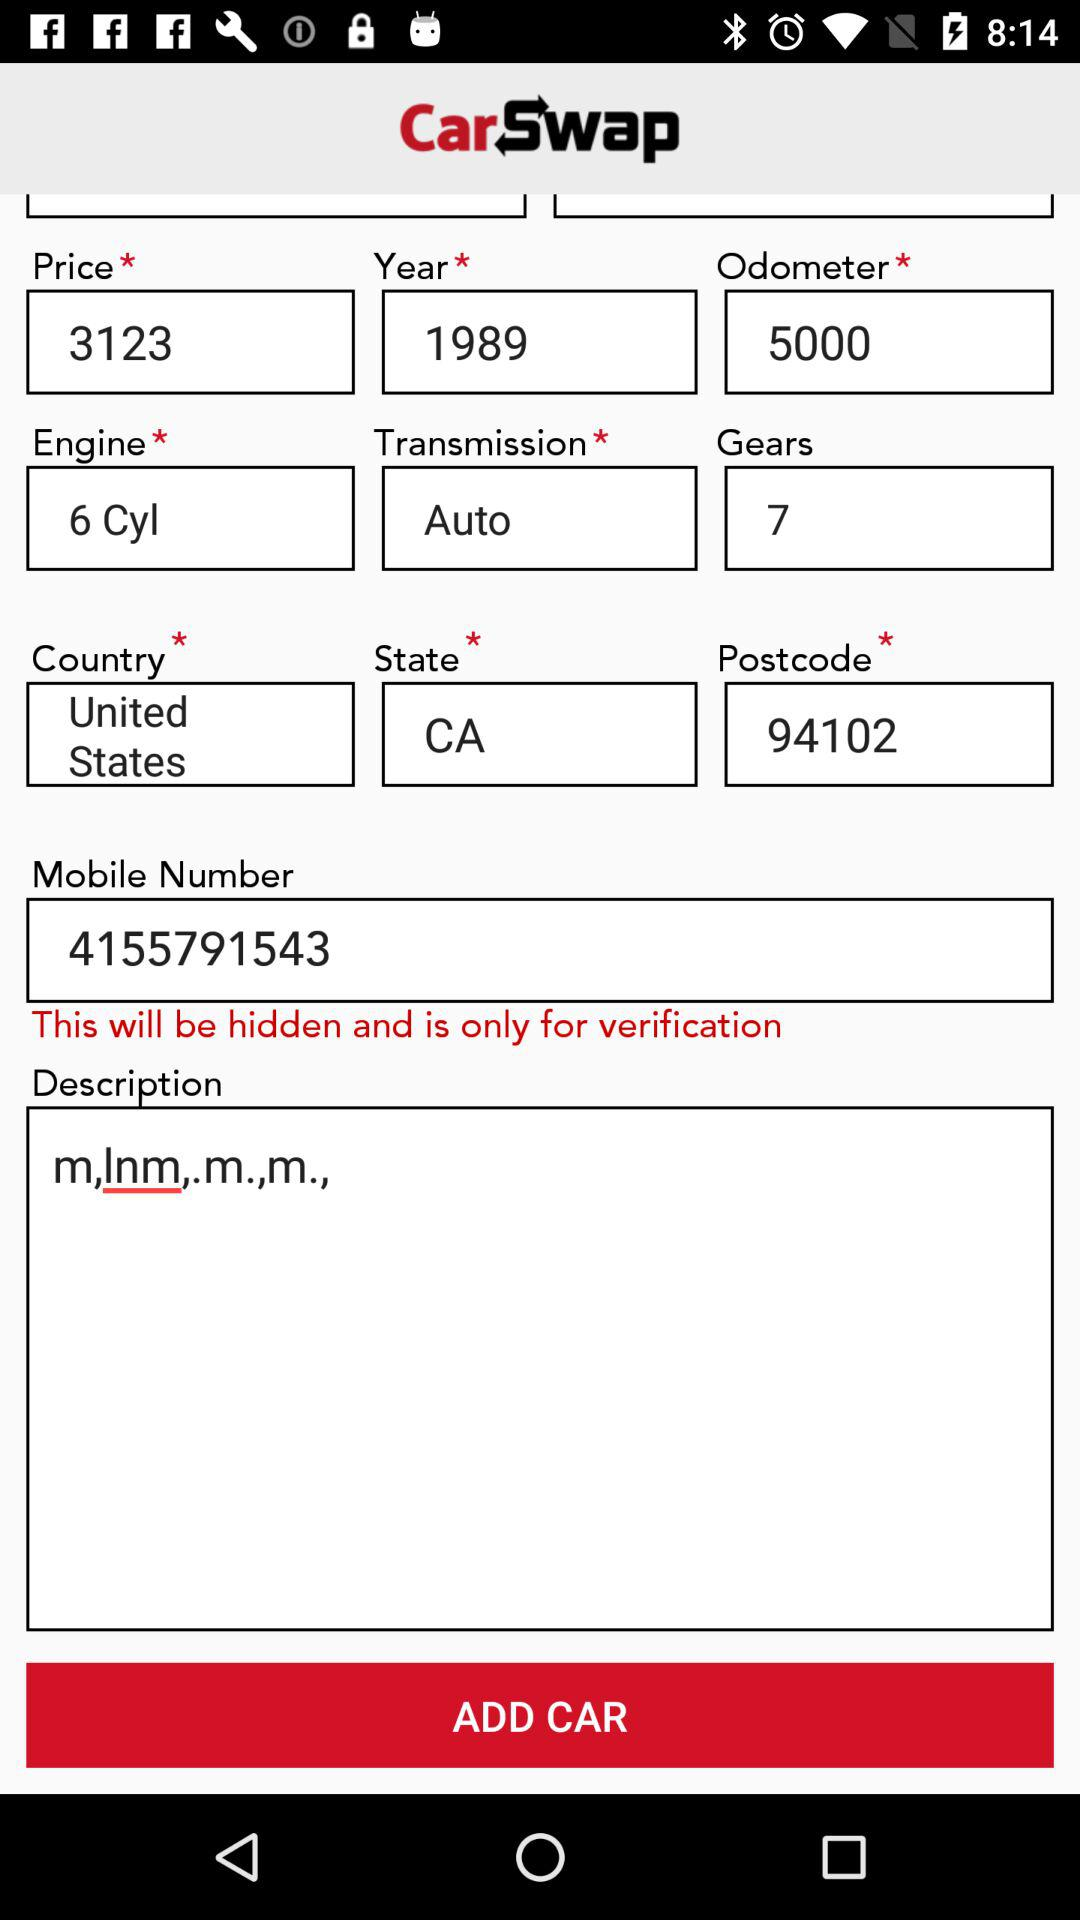How many gears does the car have?
Answer the question using a single word or phrase. 7 